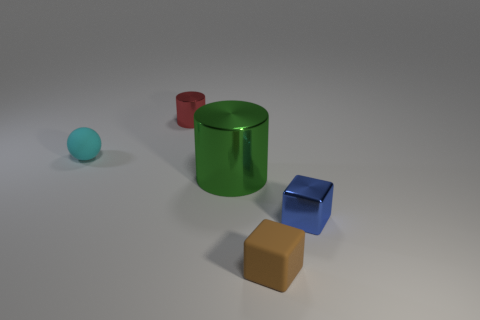Add 2 red shiny things. How many objects exist? 7 Subtract 1 cylinders. How many cylinders are left? 1 Subtract 1 cyan balls. How many objects are left? 4 Subtract all blocks. How many objects are left? 3 Subtract all green balls. Subtract all yellow cylinders. How many balls are left? 1 Subtract all yellow cylinders. How many blue blocks are left? 1 Subtract all spheres. Subtract all purple matte balls. How many objects are left? 4 Add 3 rubber spheres. How many rubber spheres are left? 4 Add 1 small yellow cylinders. How many small yellow cylinders exist? 1 